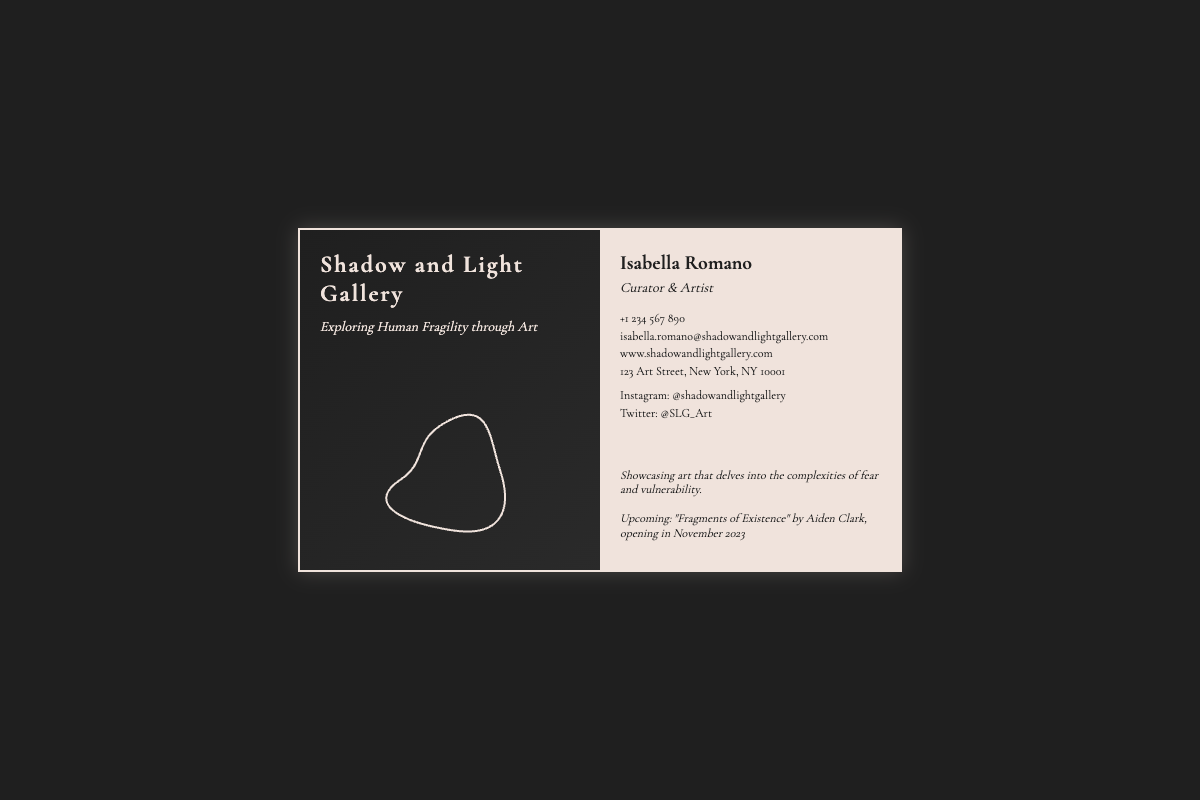What is the gallery's name? The name of the gallery is presented prominently on the business card.
Answer: Shadow and Light Gallery Who is the curator and artist? The business card clearly states the name of the curator and artist.
Answer: Isabella Romano What is the gallery's tagline? The tagline describes the focus of the gallery and is found on the front of the card.
Answer: Exploring Human Fragility through Art What is the contact email address? The contact email address is listed under the contact section on the back of the card.
Answer: isabella.romano@shadowandlightgallery.com When is the upcoming exhibit? The upcoming exhibit is noted in the gallery information on the back of the card.
Answer: November 2023 What is the name of the artist for the upcoming exhibit? The name of the artist for the exhibit is mentioned in the gallery information section.
Answer: Aiden Clark What city is the gallery located in? The address on the business card includes the city where the gallery is located.
Answer: New York What social media platform is mentioned? The social media section indicates platforms where the gallery can be found.
Answer: Instagram What type of art does the gallery showcase? The gallery information specifies the themes of the artwork showcased.
Answer: Fear and vulnerability 